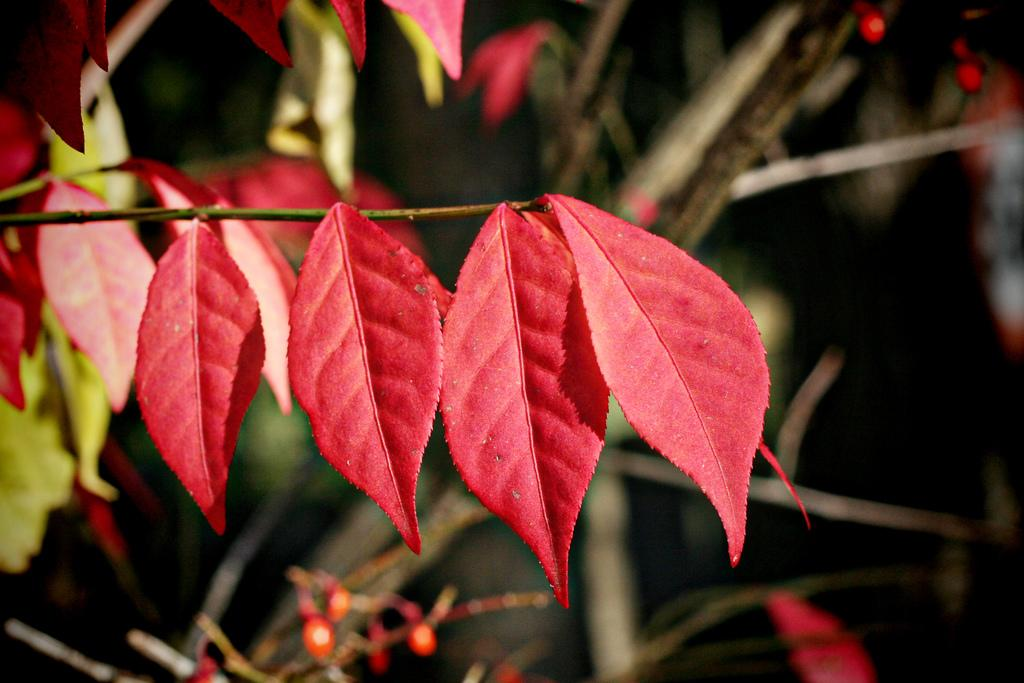What type of vegetation can be seen in the image? There are trees in the image. Can you describe any specific features of the trees? There are red leaves on a branch in the center of the image. How many mice can be seen playing in the park in the image? There are no mice or park present in the image; it features trees with red leaves on a branch. Is there a pig visible in the image? There is no pig present in the image; it features trees with red leaves on a branch. 